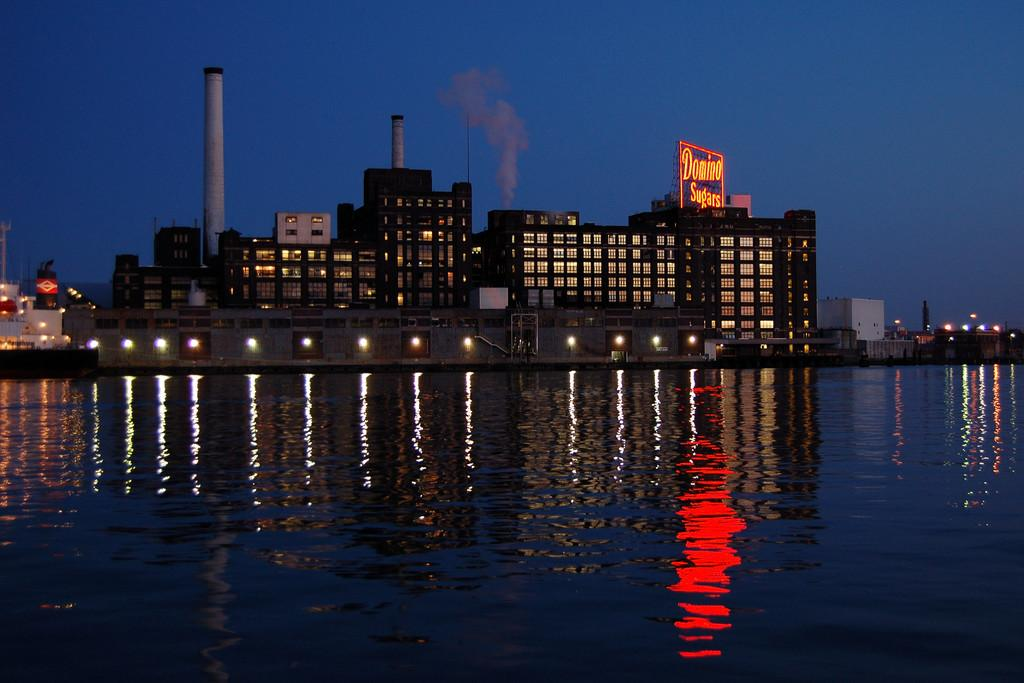What is the main subject in the center of the image? There is water in the center of the image. What is floating on the water? There are boats in the water. What else can be seen in the water? There are lights in the water. What can be seen in the background of the image? In the background, there is sky visible, as well as buildings, a wall, poles, lights, and banners. What type of table is being used to serve eggnog in the image? There is no table or eggnog present in the image. Can you tell me what type of guitar is being played in the background of the image? There is no guitar present in the image. 